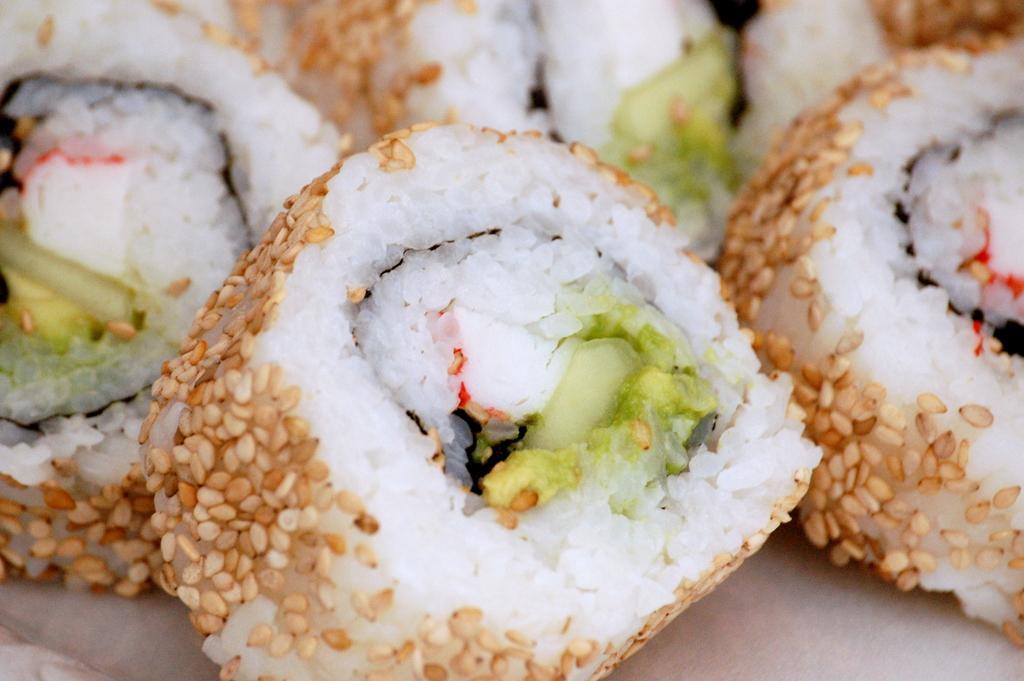How would you summarize this image in a sentence or two? In this picture I can observe food in the middle of the picture. The food is in cream and white color. 